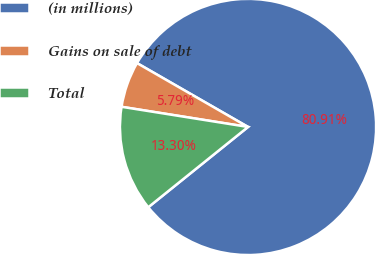<chart> <loc_0><loc_0><loc_500><loc_500><pie_chart><fcel>(in millions)<fcel>Gains on sale of debt<fcel>Total<nl><fcel>80.91%<fcel>5.79%<fcel>13.3%<nl></chart> 